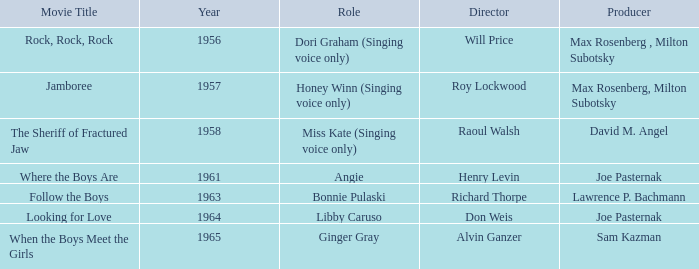Who were the producers in 1961? Joe Pasternak. 